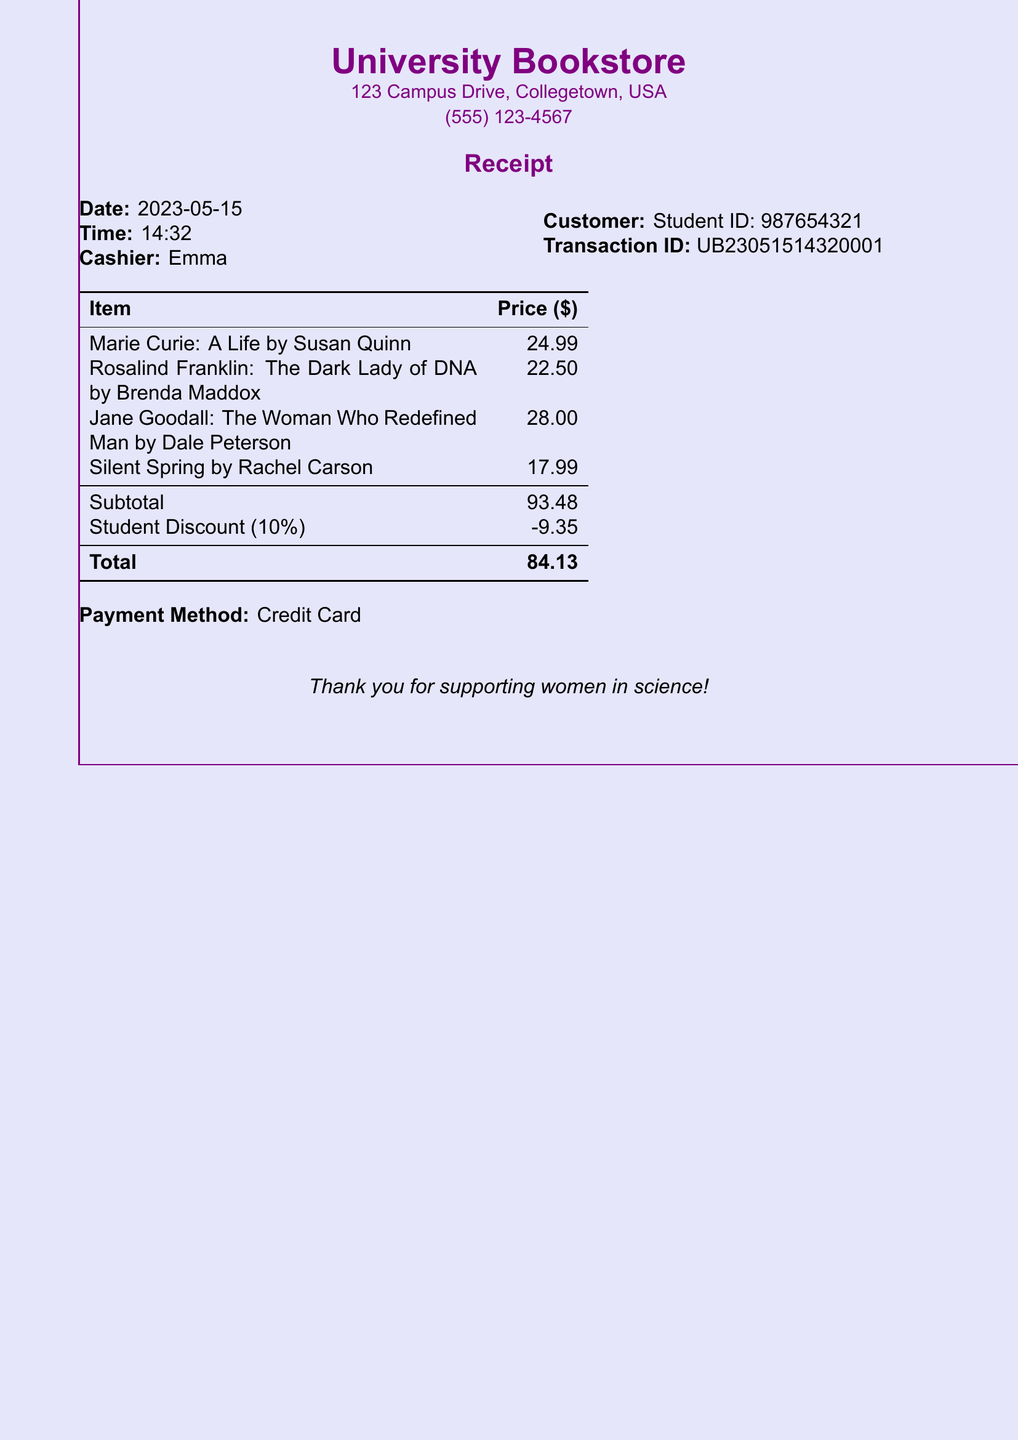What is the date of the receipt? The date of the receipt is provided at the top of the document, under the cashier information.
Answer: 2023-05-15 Who was the cashier? The cashier's name is mentioned in the receipt details section.
Answer: Emma What was the original subtotal? The subtotal is given before applying the student discount, as outlined in the table.
Answer: 93.48 What is the amount of the student discount? The student discount amount is shown just before the total in the receipt.
Answer: -9.35 What is the total amount paid? The total amount is at the bottom of the receipt after the discount is applied.
Answer: 84.13 How many items were purchased? The number of items can be counted from the list in the receipt.
Answer: 4 What is the payment method used? The payment method is mentioned before the closing message at the bottom of the receipt.
Answer: Credit Card What is the total number of biographies purchased? The receipt lists distinct titles under the itemized list for purchase, indicating biographies specifically.
Answer: 4 